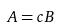Convert formula to latex. <formula><loc_0><loc_0><loc_500><loc_500>A = c B</formula> 